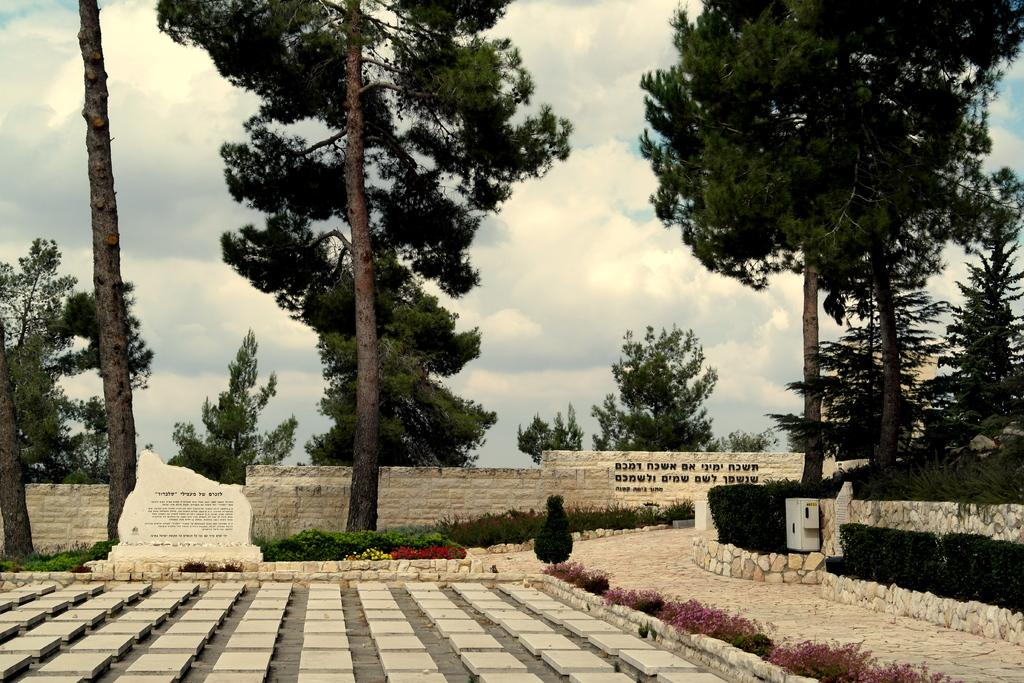What type of vegetation can be seen in the image? There are trees, plants, and flowers visible in the image. What type of surface is visible in the image? There are tiles visible in the image. Is there any text present in the image? Yes, there is text on a wall in the image. What can be seen in the background of the image? The sky is visible in the background of the image, and clouds are present in the sky. What type of kitty is playing with the paste in the image? There is no kitty or paste present in the image. What type of plants are growing on the wall in the image? The image does not show any plants growing on the wall; it only shows text on a wall. 